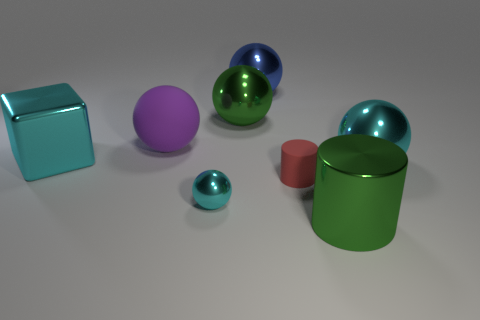There is a block that is the same size as the purple ball; what is its material?
Provide a short and direct response. Metal. Do the cylinder left of the green shiny cylinder and the large metallic ball to the right of the large green cylinder have the same color?
Offer a very short reply. No. Is there a big yellow shiny thing of the same shape as the blue metal object?
Ensure brevity in your answer.  No. There is a matte object that is the same size as the blue ball; what is its shape?
Your answer should be very brief. Sphere. How many large spheres are the same color as the metal cube?
Give a very brief answer. 1. How big is the matte thing to the left of the blue shiny ball?
Give a very brief answer. Large. What number of purple spheres have the same size as the metal cylinder?
Give a very brief answer. 1. What is the color of the tiny thing that is the same material as the large cyan ball?
Offer a terse response. Cyan. Is the number of large cyan cubes in front of the shiny cube less than the number of green shiny spheres?
Make the answer very short. Yes. The purple object that is made of the same material as the tiny cylinder is what shape?
Keep it short and to the point. Sphere. 